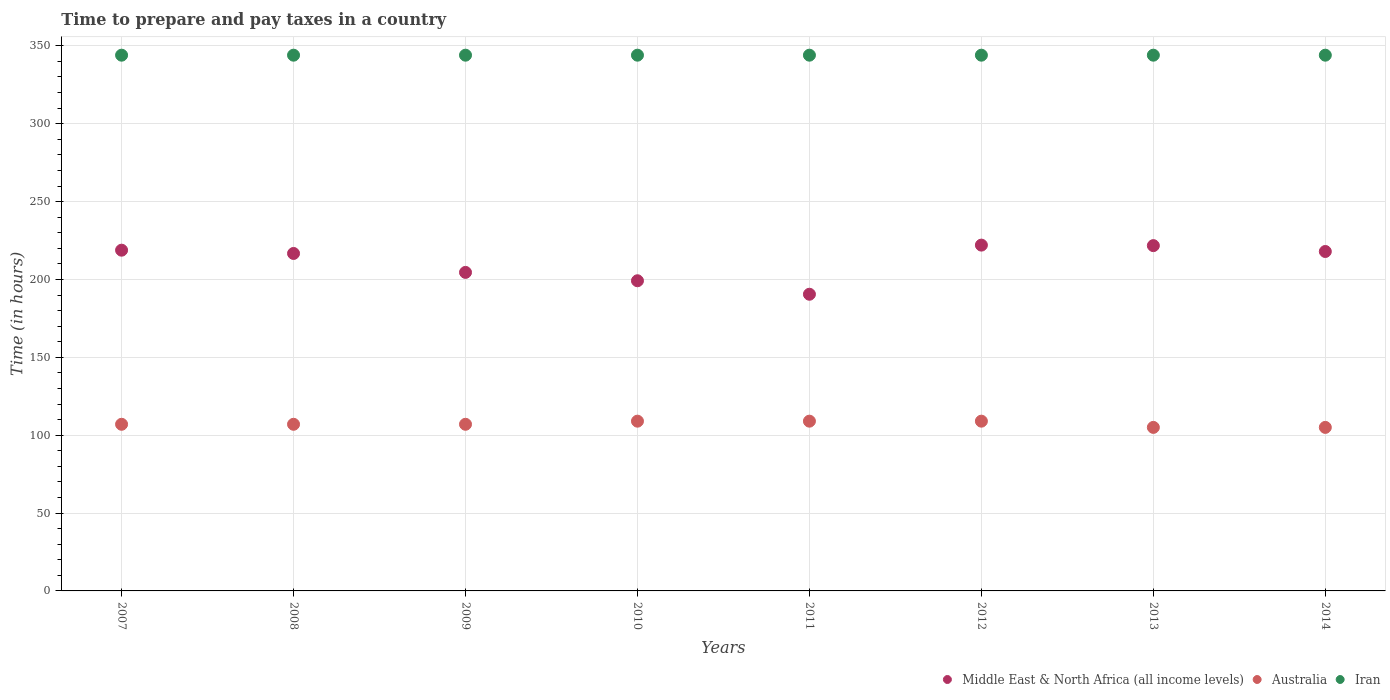What is the number of hours required to prepare and pay taxes in Australia in 2013?
Offer a terse response. 105. Across all years, what is the maximum number of hours required to prepare and pay taxes in Iran?
Provide a short and direct response. 344. Across all years, what is the minimum number of hours required to prepare and pay taxes in Iran?
Your answer should be compact. 344. In which year was the number of hours required to prepare and pay taxes in Australia maximum?
Keep it short and to the point. 2010. What is the total number of hours required to prepare and pay taxes in Australia in the graph?
Keep it short and to the point. 858. What is the difference between the number of hours required to prepare and pay taxes in Middle East & North Africa (all income levels) in 2009 and that in 2010?
Provide a succinct answer. 5.37. What is the difference between the number of hours required to prepare and pay taxes in Middle East & North Africa (all income levels) in 2013 and the number of hours required to prepare and pay taxes in Australia in 2012?
Your answer should be very brief. 112.71. What is the average number of hours required to prepare and pay taxes in Iran per year?
Provide a short and direct response. 344. In the year 2013, what is the difference between the number of hours required to prepare and pay taxes in Middle East & North Africa (all income levels) and number of hours required to prepare and pay taxes in Iran?
Your answer should be very brief. -122.29. In how many years, is the number of hours required to prepare and pay taxes in Iran greater than 40 hours?
Your answer should be very brief. 8. What is the ratio of the number of hours required to prepare and pay taxes in Australia in 2007 to that in 2010?
Provide a succinct answer. 0.98. Is the number of hours required to prepare and pay taxes in Australia in 2009 less than that in 2010?
Make the answer very short. Yes. Is the difference between the number of hours required to prepare and pay taxes in Middle East & North Africa (all income levels) in 2008 and 2010 greater than the difference between the number of hours required to prepare and pay taxes in Iran in 2008 and 2010?
Your answer should be very brief. Yes. What is the difference between the highest and the second highest number of hours required to prepare and pay taxes in Middle East & North Africa (all income levels)?
Make the answer very short. 0.33. What is the difference between the highest and the lowest number of hours required to prepare and pay taxes in Middle East & North Africa (all income levels)?
Make the answer very short. 31.55. Is the sum of the number of hours required to prepare and pay taxes in Iran in 2007 and 2011 greater than the maximum number of hours required to prepare and pay taxes in Australia across all years?
Offer a terse response. Yes. Is it the case that in every year, the sum of the number of hours required to prepare and pay taxes in Iran and number of hours required to prepare and pay taxes in Middle East & North Africa (all income levels)  is greater than the number of hours required to prepare and pay taxes in Australia?
Provide a succinct answer. Yes. Does the number of hours required to prepare and pay taxes in Iran monotonically increase over the years?
Provide a short and direct response. No. Is the number of hours required to prepare and pay taxes in Australia strictly greater than the number of hours required to prepare and pay taxes in Middle East & North Africa (all income levels) over the years?
Provide a short and direct response. No. How many dotlines are there?
Provide a succinct answer. 3. How many years are there in the graph?
Your response must be concise. 8. What is the difference between two consecutive major ticks on the Y-axis?
Ensure brevity in your answer.  50. Are the values on the major ticks of Y-axis written in scientific E-notation?
Your answer should be compact. No. Does the graph contain any zero values?
Ensure brevity in your answer.  No. How are the legend labels stacked?
Provide a succinct answer. Horizontal. What is the title of the graph?
Your answer should be very brief. Time to prepare and pay taxes in a country. Does "St. Martin (French part)" appear as one of the legend labels in the graph?
Offer a very short reply. No. What is the label or title of the X-axis?
Ensure brevity in your answer.  Years. What is the label or title of the Y-axis?
Ensure brevity in your answer.  Time (in hours). What is the Time (in hours) in Middle East & North Africa (all income levels) in 2007?
Your answer should be compact. 218.79. What is the Time (in hours) of Australia in 2007?
Ensure brevity in your answer.  107. What is the Time (in hours) of Iran in 2007?
Give a very brief answer. 344. What is the Time (in hours) in Middle East & North Africa (all income levels) in 2008?
Offer a very short reply. 216.68. What is the Time (in hours) in Australia in 2008?
Keep it short and to the point. 107. What is the Time (in hours) of Iran in 2008?
Provide a short and direct response. 344. What is the Time (in hours) of Middle East & North Africa (all income levels) in 2009?
Your answer should be very brief. 204.53. What is the Time (in hours) in Australia in 2009?
Keep it short and to the point. 107. What is the Time (in hours) in Iran in 2009?
Your response must be concise. 344. What is the Time (in hours) in Middle East & North Africa (all income levels) in 2010?
Make the answer very short. 199.16. What is the Time (in hours) of Australia in 2010?
Provide a short and direct response. 109. What is the Time (in hours) in Iran in 2010?
Make the answer very short. 344. What is the Time (in hours) of Middle East & North Africa (all income levels) in 2011?
Offer a terse response. 190.5. What is the Time (in hours) of Australia in 2011?
Your answer should be very brief. 109. What is the Time (in hours) in Iran in 2011?
Offer a terse response. 344. What is the Time (in hours) of Middle East & North Africa (all income levels) in 2012?
Your answer should be compact. 222.05. What is the Time (in hours) of Australia in 2012?
Your answer should be very brief. 109. What is the Time (in hours) of Iran in 2012?
Give a very brief answer. 344. What is the Time (in hours) in Middle East & North Africa (all income levels) in 2013?
Your answer should be very brief. 221.71. What is the Time (in hours) of Australia in 2013?
Your answer should be compact. 105. What is the Time (in hours) of Iran in 2013?
Provide a short and direct response. 344. What is the Time (in hours) of Middle East & North Africa (all income levels) in 2014?
Offer a very short reply. 217.95. What is the Time (in hours) in Australia in 2014?
Provide a short and direct response. 105. What is the Time (in hours) of Iran in 2014?
Offer a terse response. 344. Across all years, what is the maximum Time (in hours) of Middle East & North Africa (all income levels)?
Your response must be concise. 222.05. Across all years, what is the maximum Time (in hours) in Australia?
Your response must be concise. 109. Across all years, what is the maximum Time (in hours) in Iran?
Your answer should be very brief. 344. Across all years, what is the minimum Time (in hours) of Middle East & North Africa (all income levels)?
Make the answer very short. 190.5. Across all years, what is the minimum Time (in hours) of Australia?
Give a very brief answer. 105. Across all years, what is the minimum Time (in hours) in Iran?
Offer a terse response. 344. What is the total Time (in hours) of Middle East & North Africa (all income levels) in the graph?
Ensure brevity in your answer.  1691.37. What is the total Time (in hours) of Australia in the graph?
Keep it short and to the point. 858. What is the total Time (in hours) in Iran in the graph?
Your answer should be compact. 2752. What is the difference between the Time (in hours) in Middle East & North Africa (all income levels) in 2007 and that in 2008?
Keep it short and to the point. 2.11. What is the difference between the Time (in hours) of Australia in 2007 and that in 2008?
Your response must be concise. 0. What is the difference between the Time (in hours) of Middle East & North Africa (all income levels) in 2007 and that in 2009?
Provide a short and direct response. 14.26. What is the difference between the Time (in hours) of Middle East & North Africa (all income levels) in 2007 and that in 2010?
Provide a succinct answer. 19.63. What is the difference between the Time (in hours) of Iran in 2007 and that in 2010?
Give a very brief answer. 0. What is the difference between the Time (in hours) of Middle East & North Africa (all income levels) in 2007 and that in 2011?
Offer a very short reply. 28.29. What is the difference between the Time (in hours) in Australia in 2007 and that in 2011?
Offer a terse response. -2. What is the difference between the Time (in hours) in Iran in 2007 and that in 2011?
Provide a succinct answer. 0. What is the difference between the Time (in hours) in Middle East & North Africa (all income levels) in 2007 and that in 2012?
Ensure brevity in your answer.  -3.26. What is the difference between the Time (in hours) in Australia in 2007 and that in 2012?
Provide a short and direct response. -2. What is the difference between the Time (in hours) of Middle East & North Africa (all income levels) in 2007 and that in 2013?
Give a very brief answer. -2.92. What is the difference between the Time (in hours) in Iran in 2007 and that in 2013?
Make the answer very short. 0. What is the difference between the Time (in hours) in Middle East & North Africa (all income levels) in 2007 and that in 2014?
Your answer should be very brief. 0.84. What is the difference between the Time (in hours) of Middle East & North Africa (all income levels) in 2008 and that in 2009?
Offer a very short reply. 12.16. What is the difference between the Time (in hours) of Middle East & North Africa (all income levels) in 2008 and that in 2010?
Your answer should be compact. 17.53. What is the difference between the Time (in hours) of Iran in 2008 and that in 2010?
Your answer should be very brief. 0. What is the difference between the Time (in hours) in Middle East & North Africa (all income levels) in 2008 and that in 2011?
Make the answer very short. 26.18. What is the difference between the Time (in hours) of Middle East & North Africa (all income levels) in 2008 and that in 2012?
Your response must be concise. -5.36. What is the difference between the Time (in hours) of Australia in 2008 and that in 2012?
Ensure brevity in your answer.  -2. What is the difference between the Time (in hours) of Middle East & North Africa (all income levels) in 2008 and that in 2013?
Offer a terse response. -5.03. What is the difference between the Time (in hours) of Iran in 2008 and that in 2013?
Keep it short and to the point. 0. What is the difference between the Time (in hours) of Middle East & North Africa (all income levels) in 2008 and that in 2014?
Your response must be concise. -1.27. What is the difference between the Time (in hours) of Middle East & North Africa (all income levels) in 2009 and that in 2010?
Make the answer very short. 5.37. What is the difference between the Time (in hours) of Australia in 2009 and that in 2010?
Your answer should be compact. -2. What is the difference between the Time (in hours) in Middle East & North Africa (all income levels) in 2009 and that in 2011?
Your answer should be compact. 14.03. What is the difference between the Time (in hours) in Australia in 2009 and that in 2011?
Offer a very short reply. -2. What is the difference between the Time (in hours) in Middle East & North Africa (all income levels) in 2009 and that in 2012?
Your response must be concise. -17.52. What is the difference between the Time (in hours) of Australia in 2009 and that in 2012?
Make the answer very short. -2. What is the difference between the Time (in hours) in Middle East & North Africa (all income levels) in 2009 and that in 2013?
Provide a succinct answer. -17.19. What is the difference between the Time (in hours) of Australia in 2009 and that in 2013?
Your response must be concise. 2. What is the difference between the Time (in hours) in Iran in 2009 and that in 2013?
Ensure brevity in your answer.  0. What is the difference between the Time (in hours) in Middle East & North Africa (all income levels) in 2009 and that in 2014?
Provide a succinct answer. -13.43. What is the difference between the Time (in hours) of Australia in 2009 and that in 2014?
Your answer should be compact. 2. What is the difference between the Time (in hours) of Iran in 2009 and that in 2014?
Ensure brevity in your answer.  0. What is the difference between the Time (in hours) in Middle East & North Africa (all income levels) in 2010 and that in 2011?
Your response must be concise. 8.66. What is the difference between the Time (in hours) in Iran in 2010 and that in 2011?
Provide a succinct answer. 0. What is the difference between the Time (in hours) in Middle East & North Africa (all income levels) in 2010 and that in 2012?
Offer a very short reply. -22.89. What is the difference between the Time (in hours) in Middle East & North Africa (all income levels) in 2010 and that in 2013?
Ensure brevity in your answer.  -22.56. What is the difference between the Time (in hours) of Iran in 2010 and that in 2013?
Provide a short and direct response. 0. What is the difference between the Time (in hours) of Middle East & North Africa (all income levels) in 2010 and that in 2014?
Provide a succinct answer. -18.79. What is the difference between the Time (in hours) in Middle East & North Africa (all income levels) in 2011 and that in 2012?
Your response must be concise. -31.55. What is the difference between the Time (in hours) in Australia in 2011 and that in 2012?
Make the answer very short. 0. What is the difference between the Time (in hours) of Iran in 2011 and that in 2012?
Offer a very short reply. 0. What is the difference between the Time (in hours) of Middle East & North Africa (all income levels) in 2011 and that in 2013?
Offer a terse response. -31.21. What is the difference between the Time (in hours) of Middle East & North Africa (all income levels) in 2011 and that in 2014?
Your answer should be very brief. -27.45. What is the difference between the Time (in hours) in Middle East & North Africa (all income levels) in 2012 and that in 2013?
Provide a succinct answer. 0.33. What is the difference between the Time (in hours) in Iran in 2012 and that in 2013?
Provide a short and direct response. 0. What is the difference between the Time (in hours) of Middle East & North Africa (all income levels) in 2012 and that in 2014?
Make the answer very short. 4.1. What is the difference between the Time (in hours) of Australia in 2012 and that in 2014?
Offer a terse response. 4. What is the difference between the Time (in hours) of Middle East & North Africa (all income levels) in 2013 and that in 2014?
Your answer should be compact. 3.76. What is the difference between the Time (in hours) in Australia in 2013 and that in 2014?
Ensure brevity in your answer.  0. What is the difference between the Time (in hours) in Iran in 2013 and that in 2014?
Offer a terse response. 0. What is the difference between the Time (in hours) in Middle East & North Africa (all income levels) in 2007 and the Time (in hours) in Australia in 2008?
Provide a short and direct response. 111.79. What is the difference between the Time (in hours) of Middle East & North Africa (all income levels) in 2007 and the Time (in hours) of Iran in 2008?
Provide a short and direct response. -125.21. What is the difference between the Time (in hours) of Australia in 2007 and the Time (in hours) of Iran in 2008?
Provide a short and direct response. -237. What is the difference between the Time (in hours) of Middle East & North Africa (all income levels) in 2007 and the Time (in hours) of Australia in 2009?
Your response must be concise. 111.79. What is the difference between the Time (in hours) of Middle East & North Africa (all income levels) in 2007 and the Time (in hours) of Iran in 2009?
Offer a very short reply. -125.21. What is the difference between the Time (in hours) in Australia in 2007 and the Time (in hours) in Iran in 2009?
Ensure brevity in your answer.  -237. What is the difference between the Time (in hours) of Middle East & North Africa (all income levels) in 2007 and the Time (in hours) of Australia in 2010?
Give a very brief answer. 109.79. What is the difference between the Time (in hours) of Middle East & North Africa (all income levels) in 2007 and the Time (in hours) of Iran in 2010?
Provide a short and direct response. -125.21. What is the difference between the Time (in hours) in Australia in 2007 and the Time (in hours) in Iran in 2010?
Keep it short and to the point. -237. What is the difference between the Time (in hours) of Middle East & North Africa (all income levels) in 2007 and the Time (in hours) of Australia in 2011?
Ensure brevity in your answer.  109.79. What is the difference between the Time (in hours) of Middle East & North Africa (all income levels) in 2007 and the Time (in hours) of Iran in 2011?
Provide a succinct answer. -125.21. What is the difference between the Time (in hours) of Australia in 2007 and the Time (in hours) of Iran in 2011?
Offer a very short reply. -237. What is the difference between the Time (in hours) of Middle East & North Africa (all income levels) in 2007 and the Time (in hours) of Australia in 2012?
Offer a terse response. 109.79. What is the difference between the Time (in hours) in Middle East & North Africa (all income levels) in 2007 and the Time (in hours) in Iran in 2012?
Give a very brief answer. -125.21. What is the difference between the Time (in hours) of Australia in 2007 and the Time (in hours) of Iran in 2012?
Your answer should be compact. -237. What is the difference between the Time (in hours) of Middle East & North Africa (all income levels) in 2007 and the Time (in hours) of Australia in 2013?
Make the answer very short. 113.79. What is the difference between the Time (in hours) in Middle East & North Africa (all income levels) in 2007 and the Time (in hours) in Iran in 2013?
Ensure brevity in your answer.  -125.21. What is the difference between the Time (in hours) of Australia in 2007 and the Time (in hours) of Iran in 2013?
Provide a succinct answer. -237. What is the difference between the Time (in hours) in Middle East & North Africa (all income levels) in 2007 and the Time (in hours) in Australia in 2014?
Your response must be concise. 113.79. What is the difference between the Time (in hours) in Middle East & North Africa (all income levels) in 2007 and the Time (in hours) in Iran in 2014?
Give a very brief answer. -125.21. What is the difference between the Time (in hours) of Australia in 2007 and the Time (in hours) of Iran in 2014?
Ensure brevity in your answer.  -237. What is the difference between the Time (in hours) of Middle East & North Africa (all income levels) in 2008 and the Time (in hours) of Australia in 2009?
Give a very brief answer. 109.68. What is the difference between the Time (in hours) in Middle East & North Africa (all income levels) in 2008 and the Time (in hours) in Iran in 2009?
Give a very brief answer. -127.32. What is the difference between the Time (in hours) of Australia in 2008 and the Time (in hours) of Iran in 2009?
Your answer should be compact. -237. What is the difference between the Time (in hours) in Middle East & North Africa (all income levels) in 2008 and the Time (in hours) in Australia in 2010?
Keep it short and to the point. 107.68. What is the difference between the Time (in hours) of Middle East & North Africa (all income levels) in 2008 and the Time (in hours) of Iran in 2010?
Give a very brief answer. -127.32. What is the difference between the Time (in hours) in Australia in 2008 and the Time (in hours) in Iran in 2010?
Your answer should be very brief. -237. What is the difference between the Time (in hours) in Middle East & North Africa (all income levels) in 2008 and the Time (in hours) in Australia in 2011?
Offer a terse response. 107.68. What is the difference between the Time (in hours) in Middle East & North Africa (all income levels) in 2008 and the Time (in hours) in Iran in 2011?
Provide a short and direct response. -127.32. What is the difference between the Time (in hours) in Australia in 2008 and the Time (in hours) in Iran in 2011?
Your response must be concise. -237. What is the difference between the Time (in hours) in Middle East & North Africa (all income levels) in 2008 and the Time (in hours) in Australia in 2012?
Ensure brevity in your answer.  107.68. What is the difference between the Time (in hours) of Middle East & North Africa (all income levels) in 2008 and the Time (in hours) of Iran in 2012?
Keep it short and to the point. -127.32. What is the difference between the Time (in hours) in Australia in 2008 and the Time (in hours) in Iran in 2012?
Your answer should be compact. -237. What is the difference between the Time (in hours) in Middle East & North Africa (all income levels) in 2008 and the Time (in hours) in Australia in 2013?
Provide a short and direct response. 111.68. What is the difference between the Time (in hours) of Middle East & North Africa (all income levels) in 2008 and the Time (in hours) of Iran in 2013?
Provide a succinct answer. -127.32. What is the difference between the Time (in hours) of Australia in 2008 and the Time (in hours) of Iran in 2013?
Provide a short and direct response. -237. What is the difference between the Time (in hours) of Middle East & North Africa (all income levels) in 2008 and the Time (in hours) of Australia in 2014?
Ensure brevity in your answer.  111.68. What is the difference between the Time (in hours) in Middle East & North Africa (all income levels) in 2008 and the Time (in hours) in Iran in 2014?
Provide a succinct answer. -127.32. What is the difference between the Time (in hours) of Australia in 2008 and the Time (in hours) of Iran in 2014?
Your answer should be very brief. -237. What is the difference between the Time (in hours) of Middle East & North Africa (all income levels) in 2009 and the Time (in hours) of Australia in 2010?
Your response must be concise. 95.53. What is the difference between the Time (in hours) in Middle East & North Africa (all income levels) in 2009 and the Time (in hours) in Iran in 2010?
Provide a succinct answer. -139.47. What is the difference between the Time (in hours) of Australia in 2009 and the Time (in hours) of Iran in 2010?
Provide a succinct answer. -237. What is the difference between the Time (in hours) of Middle East & North Africa (all income levels) in 2009 and the Time (in hours) of Australia in 2011?
Keep it short and to the point. 95.53. What is the difference between the Time (in hours) of Middle East & North Africa (all income levels) in 2009 and the Time (in hours) of Iran in 2011?
Provide a short and direct response. -139.47. What is the difference between the Time (in hours) of Australia in 2009 and the Time (in hours) of Iran in 2011?
Give a very brief answer. -237. What is the difference between the Time (in hours) of Middle East & North Africa (all income levels) in 2009 and the Time (in hours) of Australia in 2012?
Your response must be concise. 95.53. What is the difference between the Time (in hours) in Middle East & North Africa (all income levels) in 2009 and the Time (in hours) in Iran in 2012?
Your answer should be very brief. -139.47. What is the difference between the Time (in hours) of Australia in 2009 and the Time (in hours) of Iran in 2012?
Your answer should be compact. -237. What is the difference between the Time (in hours) in Middle East & North Africa (all income levels) in 2009 and the Time (in hours) in Australia in 2013?
Your answer should be compact. 99.53. What is the difference between the Time (in hours) in Middle East & North Africa (all income levels) in 2009 and the Time (in hours) in Iran in 2013?
Your answer should be very brief. -139.47. What is the difference between the Time (in hours) in Australia in 2009 and the Time (in hours) in Iran in 2013?
Keep it short and to the point. -237. What is the difference between the Time (in hours) in Middle East & North Africa (all income levels) in 2009 and the Time (in hours) in Australia in 2014?
Make the answer very short. 99.53. What is the difference between the Time (in hours) in Middle East & North Africa (all income levels) in 2009 and the Time (in hours) in Iran in 2014?
Provide a succinct answer. -139.47. What is the difference between the Time (in hours) in Australia in 2009 and the Time (in hours) in Iran in 2014?
Provide a succinct answer. -237. What is the difference between the Time (in hours) in Middle East & North Africa (all income levels) in 2010 and the Time (in hours) in Australia in 2011?
Provide a short and direct response. 90.16. What is the difference between the Time (in hours) in Middle East & North Africa (all income levels) in 2010 and the Time (in hours) in Iran in 2011?
Offer a terse response. -144.84. What is the difference between the Time (in hours) in Australia in 2010 and the Time (in hours) in Iran in 2011?
Keep it short and to the point. -235. What is the difference between the Time (in hours) of Middle East & North Africa (all income levels) in 2010 and the Time (in hours) of Australia in 2012?
Your answer should be very brief. 90.16. What is the difference between the Time (in hours) of Middle East & North Africa (all income levels) in 2010 and the Time (in hours) of Iran in 2012?
Offer a terse response. -144.84. What is the difference between the Time (in hours) of Australia in 2010 and the Time (in hours) of Iran in 2012?
Your answer should be compact. -235. What is the difference between the Time (in hours) of Middle East & North Africa (all income levels) in 2010 and the Time (in hours) of Australia in 2013?
Offer a terse response. 94.16. What is the difference between the Time (in hours) of Middle East & North Africa (all income levels) in 2010 and the Time (in hours) of Iran in 2013?
Make the answer very short. -144.84. What is the difference between the Time (in hours) in Australia in 2010 and the Time (in hours) in Iran in 2013?
Make the answer very short. -235. What is the difference between the Time (in hours) of Middle East & North Africa (all income levels) in 2010 and the Time (in hours) of Australia in 2014?
Give a very brief answer. 94.16. What is the difference between the Time (in hours) in Middle East & North Africa (all income levels) in 2010 and the Time (in hours) in Iran in 2014?
Provide a succinct answer. -144.84. What is the difference between the Time (in hours) of Australia in 2010 and the Time (in hours) of Iran in 2014?
Your answer should be compact. -235. What is the difference between the Time (in hours) of Middle East & North Africa (all income levels) in 2011 and the Time (in hours) of Australia in 2012?
Offer a terse response. 81.5. What is the difference between the Time (in hours) of Middle East & North Africa (all income levels) in 2011 and the Time (in hours) of Iran in 2012?
Your response must be concise. -153.5. What is the difference between the Time (in hours) of Australia in 2011 and the Time (in hours) of Iran in 2012?
Your answer should be very brief. -235. What is the difference between the Time (in hours) of Middle East & North Africa (all income levels) in 2011 and the Time (in hours) of Australia in 2013?
Your answer should be very brief. 85.5. What is the difference between the Time (in hours) in Middle East & North Africa (all income levels) in 2011 and the Time (in hours) in Iran in 2013?
Offer a terse response. -153.5. What is the difference between the Time (in hours) in Australia in 2011 and the Time (in hours) in Iran in 2013?
Make the answer very short. -235. What is the difference between the Time (in hours) in Middle East & North Africa (all income levels) in 2011 and the Time (in hours) in Australia in 2014?
Offer a very short reply. 85.5. What is the difference between the Time (in hours) in Middle East & North Africa (all income levels) in 2011 and the Time (in hours) in Iran in 2014?
Make the answer very short. -153.5. What is the difference between the Time (in hours) in Australia in 2011 and the Time (in hours) in Iran in 2014?
Provide a succinct answer. -235. What is the difference between the Time (in hours) of Middle East & North Africa (all income levels) in 2012 and the Time (in hours) of Australia in 2013?
Give a very brief answer. 117.05. What is the difference between the Time (in hours) in Middle East & North Africa (all income levels) in 2012 and the Time (in hours) in Iran in 2013?
Provide a short and direct response. -121.95. What is the difference between the Time (in hours) in Australia in 2012 and the Time (in hours) in Iran in 2013?
Keep it short and to the point. -235. What is the difference between the Time (in hours) in Middle East & North Africa (all income levels) in 2012 and the Time (in hours) in Australia in 2014?
Ensure brevity in your answer.  117.05. What is the difference between the Time (in hours) in Middle East & North Africa (all income levels) in 2012 and the Time (in hours) in Iran in 2014?
Make the answer very short. -121.95. What is the difference between the Time (in hours) of Australia in 2012 and the Time (in hours) of Iran in 2014?
Your answer should be compact. -235. What is the difference between the Time (in hours) of Middle East & North Africa (all income levels) in 2013 and the Time (in hours) of Australia in 2014?
Provide a short and direct response. 116.71. What is the difference between the Time (in hours) of Middle East & North Africa (all income levels) in 2013 and the Time (in hours) of Iran in 2014?
Your answer should be very brief. -122.29. What is the difference between the Time (in hours) of Australia in 2013 and the Time (in hours) of Iran in 2014?
Ensure brevity in your answer.  -239. What is the average Time (in hours) of Middle East & North Africa (all income levels) per year?
Give a very brief answer. 211.42. What is the average Time (in hours) of Australia per year?
Provide a succinct answer. 107.25. What is the average Time (in hours) of Iran per year?
Provide a short and direct response. 344. In the year 2007, what is the difference between the Time (in hours) in Middle East & North Africa (all income levels) and Time (in hours) in Australia?
Keep it short and to the point. 111.79. In the year 2007, what is the difference between the Time (in hours) in Middle East & North Africa (all income levels) and Time (in hours) in Iran?
Make the answer very short. -125.21. In the year 2007, what is the difference between the Time (in hours) in Australia and Time (in hours) in Iran?
Give a very brief answer. -237. In the year 2008, what is the difference between the Time (in hours) in Middle East & North Africa (all income levels) and Time (in hours) in Australia?
Offer a terse response. 109.68. In the year 2008, what is the difference between the Time (in hours) of Middle East & North Africa (all income levels) and Time (in hours) of Iran?
Keep it short and to the point. -127.32. In the year 2008, what is the difference between the Time (in hours) of Australia and Time (in hours) of Iran?
Keep it short and to the point. -237. In the year 2009, what is the difference between the Time (in hours) in Middle East & North Africa (all income levels) and Time (in hours) in Australia?
Your answer should be compact. 97.53. In the year 2009, what is the difference between the Time (in hours) in Middle East & North Africa (all income levels) and Time (in hours) in Iran?
Make the answer very short. -139.47. In the year 2009, what is the difference between the Time (in hours) in Australia and Time (in hours) in Iran?
Make the answer very short. -237. In the year 2010, what is the difference between the Time (in hours) in Middle East & North Africa (all income levels) and Time (in hours) in Australia?
Offer a terse response. 90.16. In the year 2010, what is the difference between the Time (in hours) in Middle East & North Africa (all income levels) and Time (in hours) in Iran?
Provide a succinct answer. -144.84. In the year 2010, what is the difference between the Time (in hours) in Australia and Time (in hours) in Iran?
Provide a succinct answer. -235. In the year 2011, what is the difference between the Time (in hours) in Middle East & North Africa (all income levels) and Time (in hours) in Australia?
Provide a short and direct response. 81.5. In the year 2011, what is the difference between the Time (in hours) of Middle East & North Africa (all income levels) and Time (in hours) of Iran?
Offer a very short reply. -153.5. In the year 2011, what is the difference between the Time (in hours) of Australia and Time (in hours) of Iran?
Provide a short and direct response. -235. In the year 2012, what is the difference between the Time (in hours) of Middle East & North Africa (all income levels) and Time (in hours) of Australia?
Make the answer very short. 113.05. In the year 2012, what is the difference between the Time (in hours) of Middle East & North Africa (all income levels) and Time (in hours) of Iran?
Your answer should be compact. -121.95. In the year 2012, what is the difference between the Time (in hours) in Australia and Time (in hours) in Iran?
Keep it short and to the point. -235. In the year 2013, what is the difference between the Time (in hours) of Middle East & North Africa (all income levels) and Time (in hours) of Australia?
Your answer should be very brief. 116.71. In the year 2013, what is the difference between the Time (in hours) in Middle East & North Africa (all income levels) and Time (in hours) in Iran?
Offer a terse response. -122.29. In the year 2013, what is the difference between the Time (in hours) of Australia and Time (in hours) of Iran?
Ensure brevity in your answer.  -239. In the year 2014, what is the difference between the Time (in hours) of Middle East & North Africa (all income levels) and Time (in hours) of Australia?
Ensure brevity in your answer.  112.95. In the year 2014, what is the difference between the Time (in hours) in Middle East & North Africa (all income levels) and Time (in hours) in Iran?
Offer a terse response. -126.05. In the year 2014, what is the difference between the Time (in hours) of Australia and Time (in hours) of Iran?
Provide a succinct answer. -239. What is the ratio of the Time (in hours) in Middle East & North Africa (all income levels) in 2007 to that in 2008?
Ensure brevity in your answer.  1.01. What is the ratio of the Time (in hours) of Australia in 2007 to that in 2008?
Offer a terse response. 1. What is the ratio of the Time (in hours) of Middle East & North Africa (all income levels) in 2007 to that in 2009?
Keep it short and to the point. 1.07. What is the ratio of the Time (in hours) in Iran in 2007 to that in 2009?
Your response must be concise. 1. What is the ratio of the Time (in hours) of Middle East & North Africa (all income levels) in 2007 to that in 2010?
Your answer should be very brief. 1.1. What is the ratio of the Time (in hours) in Australia in 2007 to that in 2010?
Provide a short and direct response. 0.98. What is the ratio of the Time (in hours) in Iran in 2007 to that in 2010?
Ensure brevity in your answer.  1. What is the ratio of the Time (in hours) in Middle East & North Africa (all income levels) in 2007 to that in 2011?
Ensure brevity in your answer.  1.15. What is the ratio of the Time (in hours) in Australia in 2007 to that in 2011?
Make the answer very short. 0.98. What is the ratio of the Time (in hours) of Iran in 2007 to that in 2011?
Keep it short and to the point. 1. What is the ratio of the Time (in hours) in Middle East & North Africa (all income levels) in 2007 to that in 2012?
Ensure brevity in your answer.  0.99. What is the ratio of the Time (in hours) of Australia in 2007 to that in 2012?
Provide a succinct answer. 0.98. What is the ratio of the Time (in hours) in Iran in 2007 to that in 2012?
Keep it short and to the point. 1. What is the ratio of the Time (in hours) in Middle East & North Africa (all income levels) in 2007 to that in 2013?
Provide a succinct answer. 0.99. What is the ratio of the Time (in hours) in Iran in 2007 to that in 2013?
Your answer should be very brief. 1. What is the ratio of the Time (in hours) in Middle East & North Africa (all income levels) in 2007 to that in 2014?
Offer a terse response. 1. What is the ratio of the Time (in hours) of Australia in 2007 to that in 2014?
Make the answer very short. 1.02. What is the ratio of the Time (in hours) of Iran in 2007 to that in 2014?
Your answer should be compact. 1. What is the ratio of the Time (in hours) of Middle East & North Africa (all income levels) in 2008 to that in 2009?
Keep it short and to the point. 1.06. What is the ratio of the Time (in hours) in Middle East & North Africa (all income levels) in 2008 to that in 2010?
Provide a succinct answer. 1.09. What is the ratio of the Time (in hours) in Australia in 2008 to that in 2010?
Provide a succinct answer. 0.98. What is the ratio of the Time (in hours) of Middle East & North Africa (all income levels) in 2008 to that in 2011?
Ensure brevity in your answer.  1.14. What is the ratio of the Time (in hours) of Australia in 2008 to that in 2011?
Give a very brief answer. 0.98. What is the ratio of the Time (in hours) in Iran in 2008 to that in 2011?
Provide a succinct answer. 1. What is the ratio of the Time (in hours) of Middle East & North Africa (all income levels) in 2008 to that in 2012?
Your response must be concise. 0.98. What is the ratio of the Time (in hours) in Australia in 2008 to that in 2012?
Provide a succinct answer. 0.98. What is the ratio of the Time (in hours) of Middle East & North Africa (all income levels) in 2008 to that in 2013?
Make the answer very short. 0.98. What is the ratio of the Time (in hours) of Australia in 2008 to that in 2013?
Ensure brevity in your answer.  1.02. What is the ratio of the Time (in hours) in Middle East & North Africa (all income levels) in 2008 to that in 2014?
Offer a terse response. 0.99. What is the ratio of the Time (in hours) in Australia in 2008 to that in 2014?
Provide a succinct answer. 1.02. What is the ratio of the Time (in hours) of Iran in 2008 to that in 2014?
Your answer should be very brief. 1. What is the ratio of the Time (in hours) of Australia in 2009 to that in 2010?
Offer a terse response. 0.98. What is the ratio of the Time (in hours) in Iran in 2009 to that in 2010?
Your answer should be compact. 1. What is the ratio of the Time (in hours) in Middle East & North Africa (all income levels) in 2009 to that in 2011?
Give a very brief answer. 1.07. What is the ratio of the Time (in hours) in Australia in 2009 to that in 2011?
Make the answer very short. 0.98. What is the ratio of the Time (in hours) of Iran in 2009 to that in 2011?
Give a very brief answer. 1. What is the ratio of the Time (in hours) of Middle East & North Africa (all income levels) in 2009 to that in 2012?
Your answer should be very brief. 0.92. What is the ratio of the Time (in hours) in Australia in 2009 to that in 2012?
Ensure brevity in your answer.  0.98. What is the ratio of the Time (in hours) in Middle East & North Africa (all income levels) in 2009 to that in 2013?
Your answer should be very brief. 0.92. What is the ratio of the Time (in hours) in Australia in 2009 to that in 2013?
Ensure brevity in your answer.  1.02. What is the ratio of the Time (in hours) in Middle East & North Africa (all income levels) in 2009 to that in 2014?
Give a very brief answer. 0.94. What is the ratio of the Time (in hours) in Iran in 2009 to that in 2014?
Your answer should be very brief. 1. What is the ratio of the Time (in hours) of Middle East & North Africa (all income levels) in 2010 to that in 2011?
Make the answer very short. 1.05. What is the ratio of the Time (in hours) of Iran in 2010 to that in 2011?
Offer a very short reply. 1. What is the ratio of the Time (in hours) of Middle East & North Africa (all income levels) in 2010 to that in 2012?
Keep it short and to the point. 0.9. What is the ratio of the Time (in hours) in Middle East & North Africa (all income levels) in 2010 to that in 2013?
Offer a terse response. 0.9. What is the ratio of the Time (in hours) in Australia in 2010 to that in 2013?
Your answer should be compact. 1.04. What is the ratio of the Time (in hours) of Middle East & North Africa (all income levels) in 2010 to that in 2014?
Your answer should be very brief. 0.91. What is the ratio of the Time (in hours) of Australia in 2010 to that in 2014?
Ensure brevity in your answer.  1.04. What is the ratio of the Time (in hours) of Iran in 2010 to that in 2014?
Keep it short and to the point. 1. What is the ratio of the Time (in hours) of Middle East & North Africa (all income levels) in 2011 to that in 2012?
Your response must be concise. 0.86. What is the ratio of the Time (in hours) in Iran in 2011 to that in 2012?
Give a very brief answer. 1. What is the ratio of the Time (in hours) in Middle East & North Africa (all income levels) in 2011 to that in 2013?
Provide a short and direct response. 0.86. What is the ratio of the Time (in hours) of Australia in 2011 to that in 2013?
Make the answer very short. 1.04. What is the ratio of the Time (in hours) in Middle East & North Africa (all income levels) in 2011 to that in 2014?
Your answer should be very brief. 0.87. What is the ratio of the Time (in hours) in Australia in 2011 to that in 2014?
Your answer should be very brief. 1.04. What is the ratio of the Time (in hours) of Iran in 2011 to that in 2014?
Give a very brief answer. 1. What is the ratio of the Time (in hours) in Australia in 2012 to that in 2013?
Keep it short and to the point. 1.04. What is the ratio of the Time (in hours) of Middle East & North Africa (all income levels) in 2012 to that in 2014?
Offer a terse response. 1.02. What is the ratio of the Time (in hours) of Australia in 2012 to that in 2014?
Keep it short and to the point. 1.04. What is the ratio of the Time (in hours) in Iran in 2012 to that in 2014?
Your answer should be compact. 1. What is the ratio of the Time (in hours) of Middle East & North Africa (all income levels) in 2013 to that in 2014?
Give a very brief answer. 1.02. What is the ratio of the Time (in hours) of Iran in 2013 to that in 2014?
Ensure brevity in your answer.  1. What is the difference between the highest and the second highest Time (in hours) of Iran?
Make the answer very short. 0. What is the difference between the highest and the lowest Time (in hours) in Middle East & North Africa (all income levels)?
Your answer should be very brief. 31.55. What is the difference between the highest and the lowest Time (in hours) in Australia?
Your answer should be very brief. 4. 